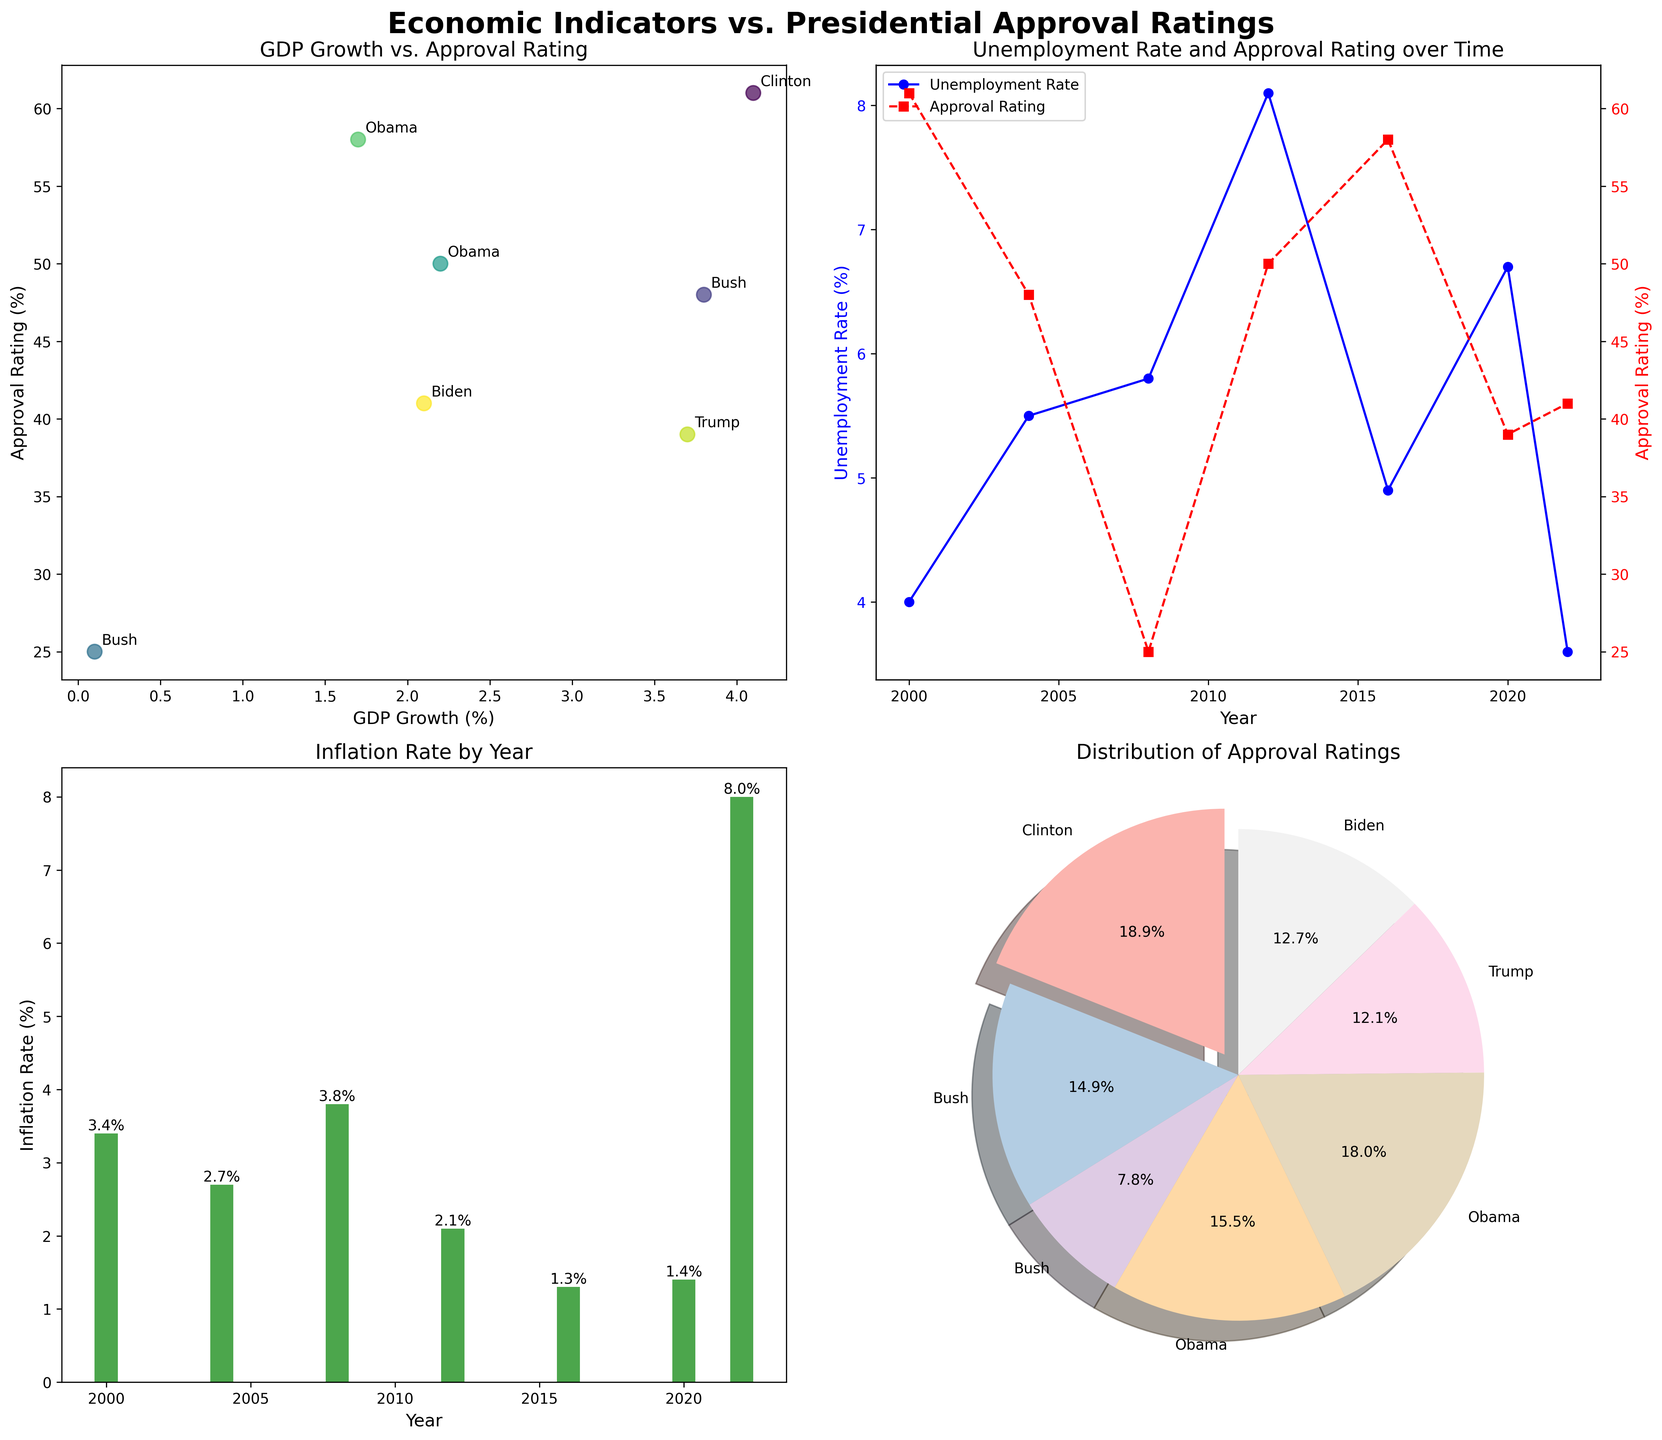What's the title of the figure? At the top of the figure, there's a title that summarizes the content of the plots.
Answer: Economic Indicators vs. Presidential Approval Ratings How many presidents are represented in the scatter plot? Each data point in the scatter plot represents a president. Count these points to find the answer.
Answer: 7 Which president had the highest approval rating and what was their GDP growth? Identify the highest point on the y-axis of the scatter plot (Approval Rating) and check which president is annotated there.
Answer: Clinton, 4.1% Which year had the highest unemployment rate and how did it correlate with the approval rating for that year? In the line plot, find the highest point in the unemployment rate line and check the corresponding year. Then, look at the approval rating for the same year.
Answer: 2012, 50% Compare the inflation rate in 2008 and 2022. Which year had a higher inflation rate? In the bar plot, locate the bars for 2008 and 2022, then compare their heights.
Answer: 2022 Describe the trend of the approval rating distribution in the pie chart. The pie chart shows the proportion of total approval ratings held by each president. Identify how the largest section and other sections compare.
Answer: Clinton has the highest proportion Which economic indicator shows a decreasing trend in the approval rating's corresponding line? Look at the overall trend of the lines in the subplot, particularly those that decrease in parallel with the approval rating line.
Answer: Unemployment Rate (in the line plot) What's the difference in approval rating between Bush's first and second term? Find Bush's approval ratings in 2004 and 2008 according to the scatter plot or legend and subtract the 2008 rating from the 2004 rating.
Answer: 23 What is the color associated with the highest approval rating in the scatter plot? All points in the scatter plot have different colors based on the year; identify the color corresponding to the highest y-point.
Answer: Yellowish-green (approx.) Which president had the lowest approval rating and what was the inflation rate that year? Identify the lowest point on the y-axis of the scatter plot (Approval Rating) and check which president is annotated there. Then look at the corresponding inflation rate for that year.
Answer: Bush (2008), 3.8% 